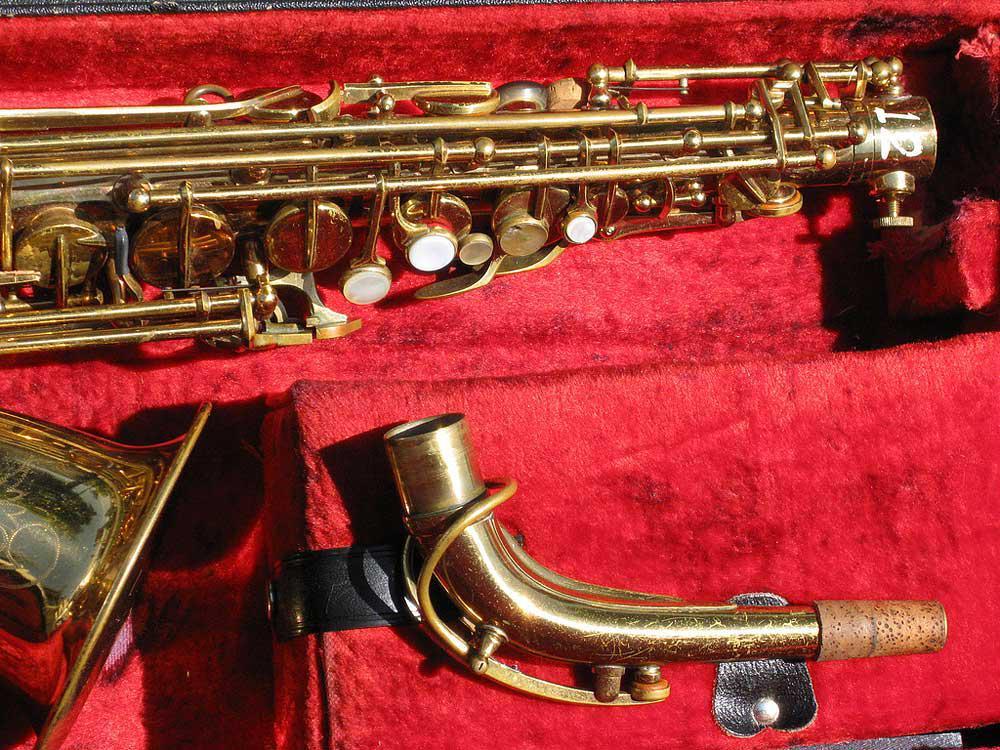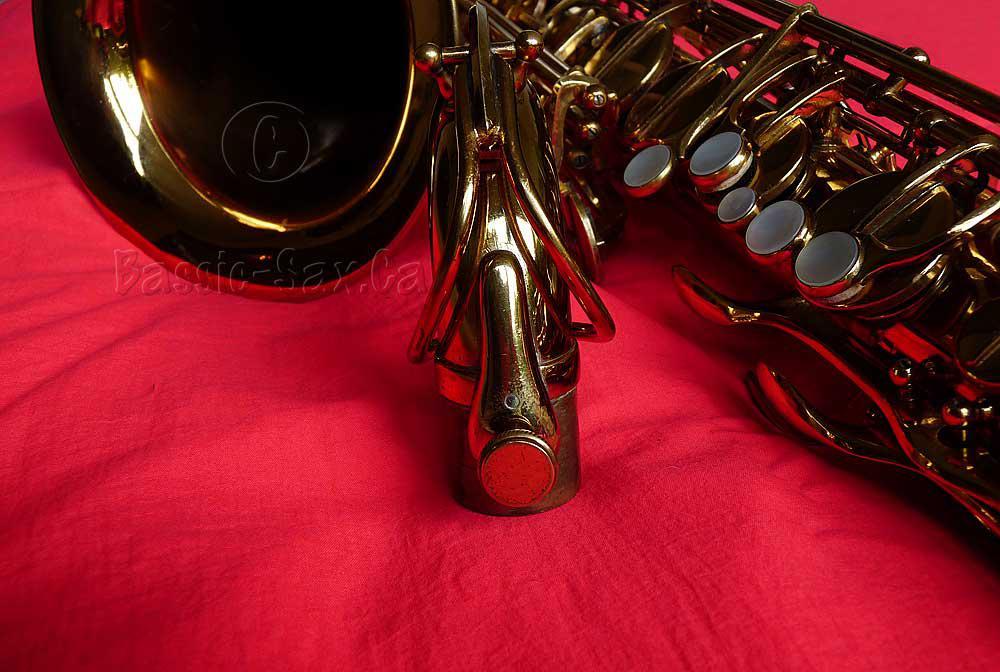The first image is the image on the left, the second image is the image on the right. Evaluate the accuracy of this statement regarding the images: "The image on the right features a silver sax in the upright position.". Is it true? Answer yes or no. No. The first image is the image on the left, the second image is the image on the right. Given the left and right images, does the statement "At least one image shows a saxophone displayed on a rich orange-red fabric." hold true? Answer yes or no. Yes. 